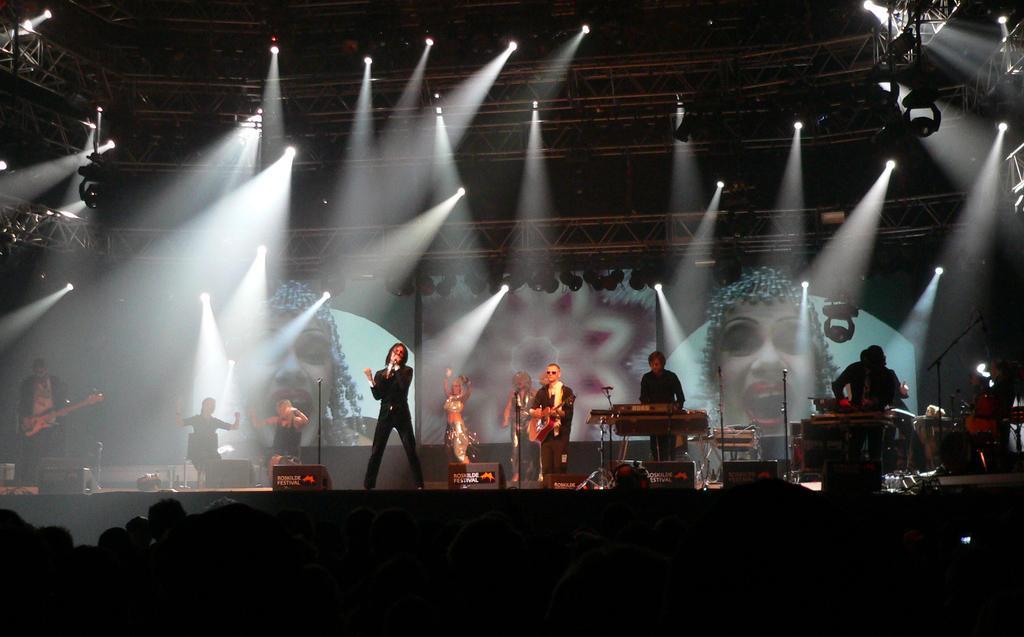In one or two sentences, can you explain what this image depicts? In this image we can see this man is playing guitar, this man is playing piano. This man standing is singing through mic. In the background we can see show lights and set. 